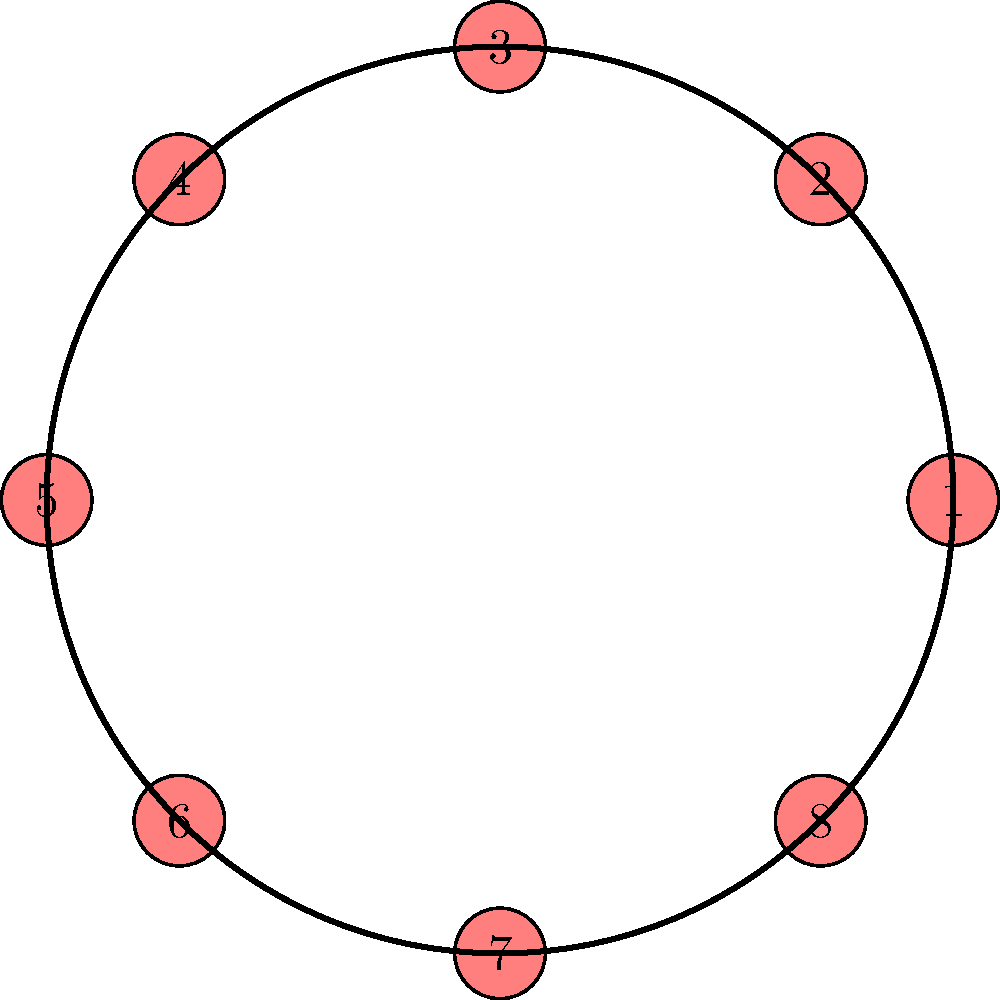A circular tin of candies contains 8 different flavors arranged as shown in the diagram. Each rotation of the tin by one position creates a new arrangement. How many unique arrangements can be created by rotating the tin, and what is the order of the cyclic group formed by these rotations? To solve this problem, we need to understand the properties of cyclic groups and how they relate to rotations:

1. The tin contains 8 candies in a circular arrangement.

2. Each rotation by one position is equivalent to shifting all candies one step clockwise.

3. The number of unique arrangements is determined by how many rotations it takes to return to the original configuration:
   - After 1 rotation, we have a new arrangement.
   - This continues until we complete a full cycle and return to the original arrangement.

4. The number of unique arrangements is equal to the number of candies, which is 8.

5. In group theory, this forms a cyclic group of order 8, denoted as $C_8$ or $\mathbb{Z}_8$.

6. The order of a group is the number of elements in the group, which in this case is the number of unique arrangements.

Therefore, there are 8 unique arrangements, and the cyclic group formed by these rotations has an order of 8.
Answer: 8 unique arrangements; order 8 